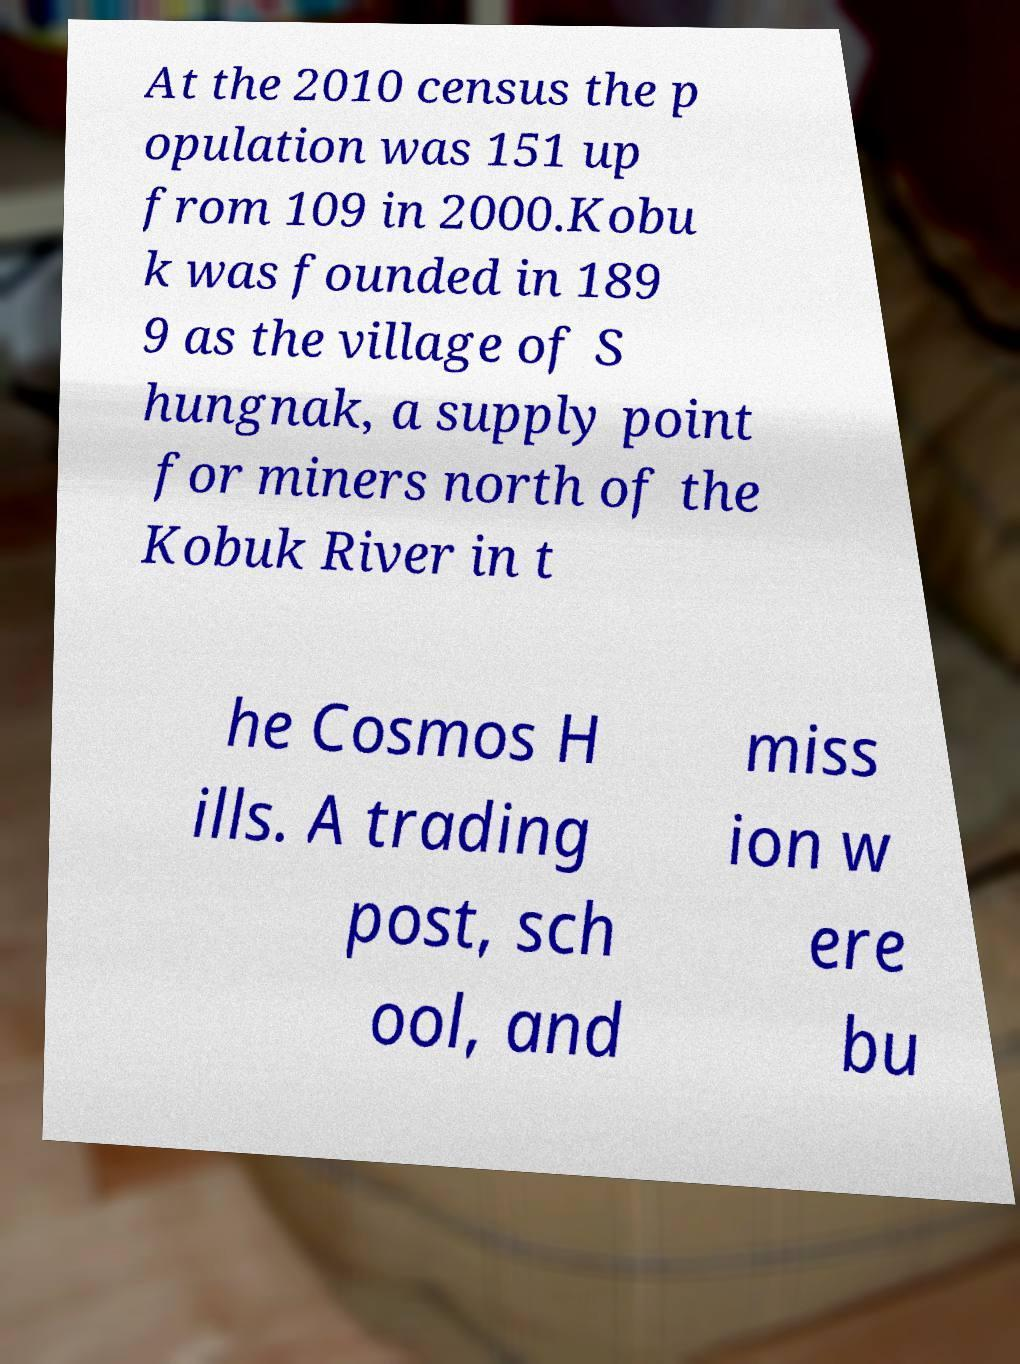Could you extract and type out the text from this image? At the 2010 census the p opulation was 151 up from 109 in 2000.Kobu k was founded in 189 9 as the village of S hungnak, a supply point for miners north of the Kobuk River in t he Cosmos H ills. A trading post, sch ool, and miss ion w ere bu 